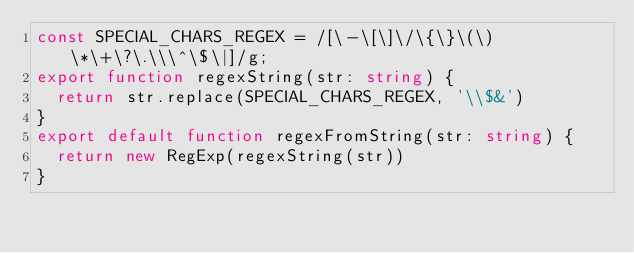Convert code to text. <code><loc_0><loc_0><loc_500><loc_500><_TypeScript_>const SPECIAL_CHARS_REGEX = /[\-\[\]\/\{\}\(\)\*\+\?\.\\\^\$\|]/g;
export function regexString(str: string) {
  return str.replace(SPECIAL_CHARS_REGEX, '\\$&')
}
export default function regexFromString(str: string) {
  return new RegExp(regexString(str))
}
</code> 